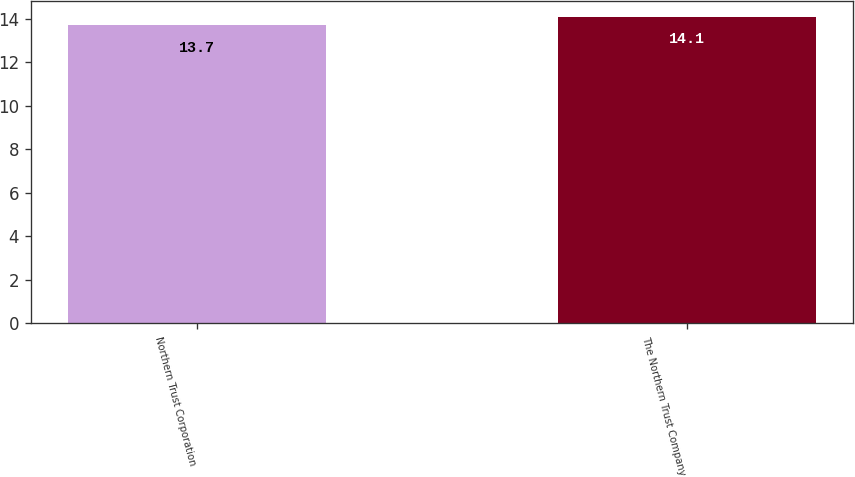<chart> <loc_0><loc_0><loc_500><loc_500><bar_chart><fcel>Northern Trust Corporation<fcel>The Northern Trust Company<nl><fcel>13.7<fcel>14.1<nl></chart> 